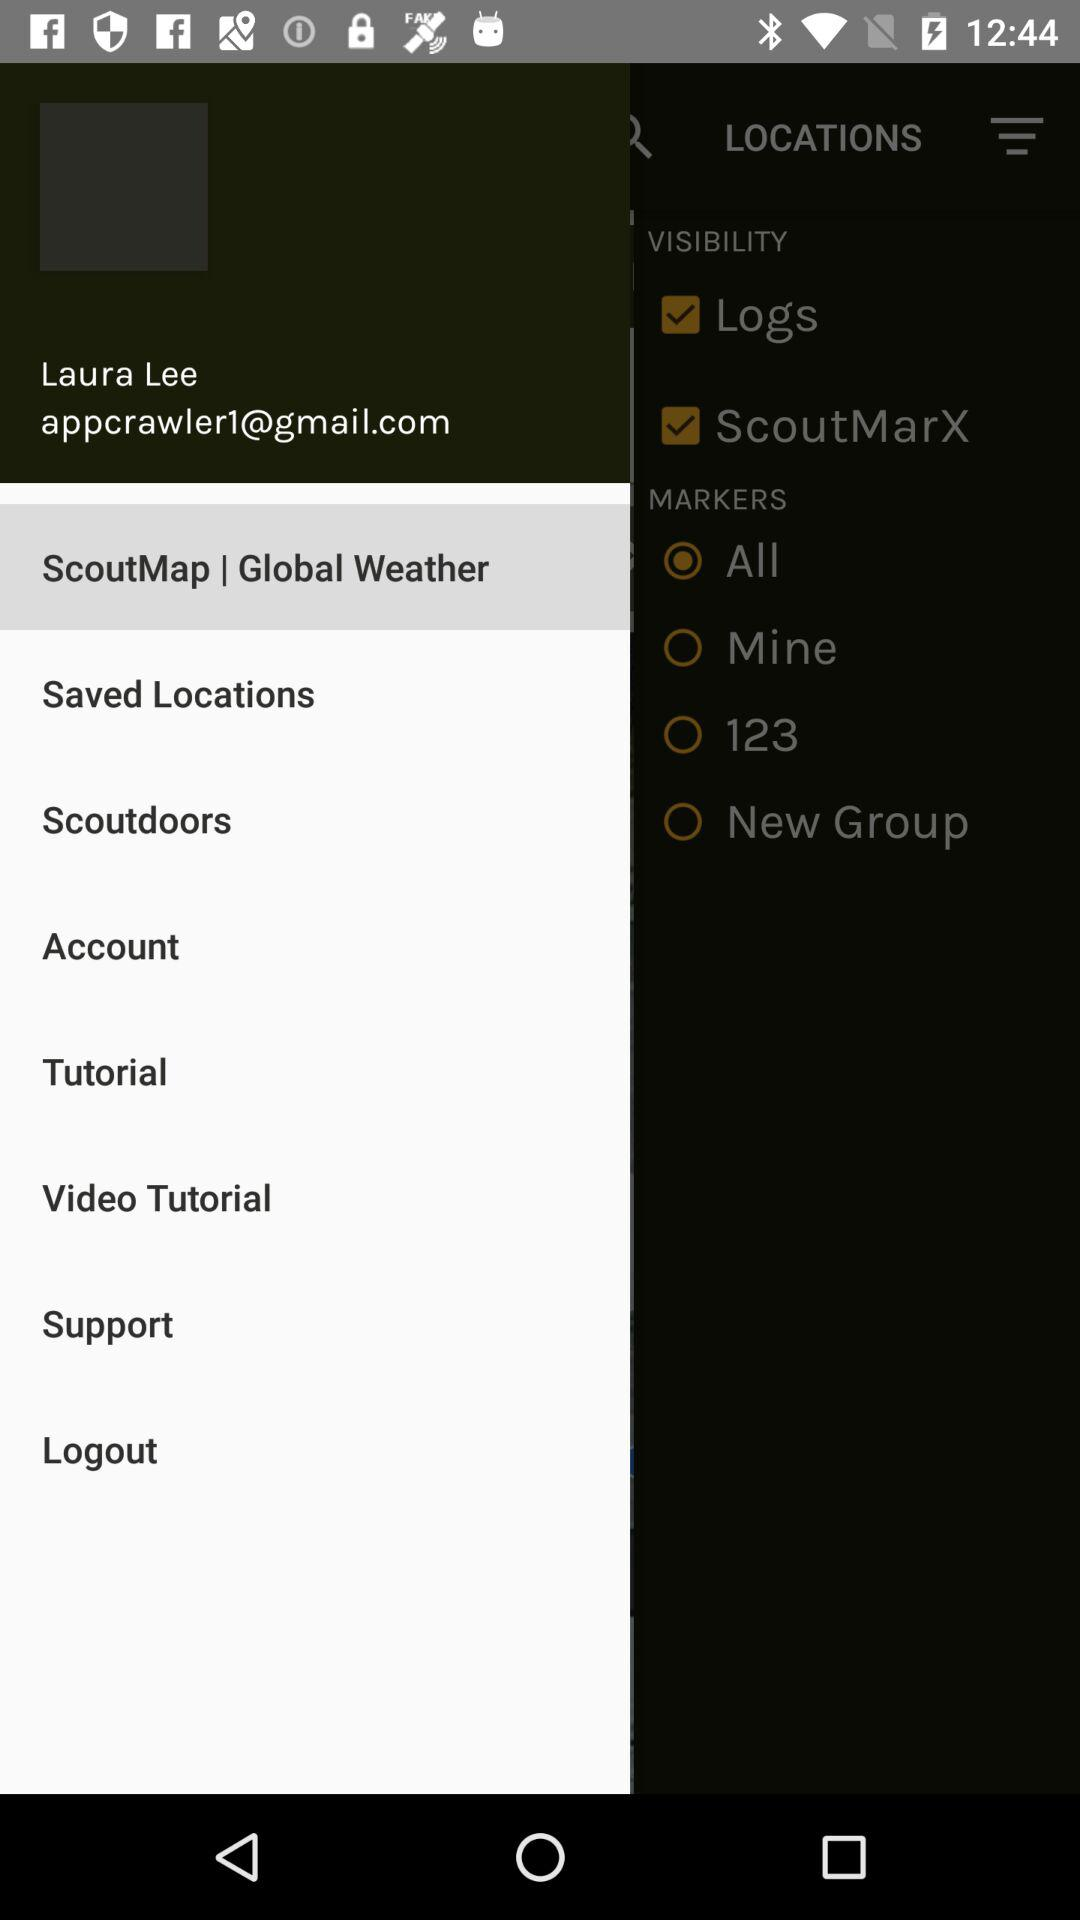What is the email address? The email address is appcrawler1@gmail.com. 